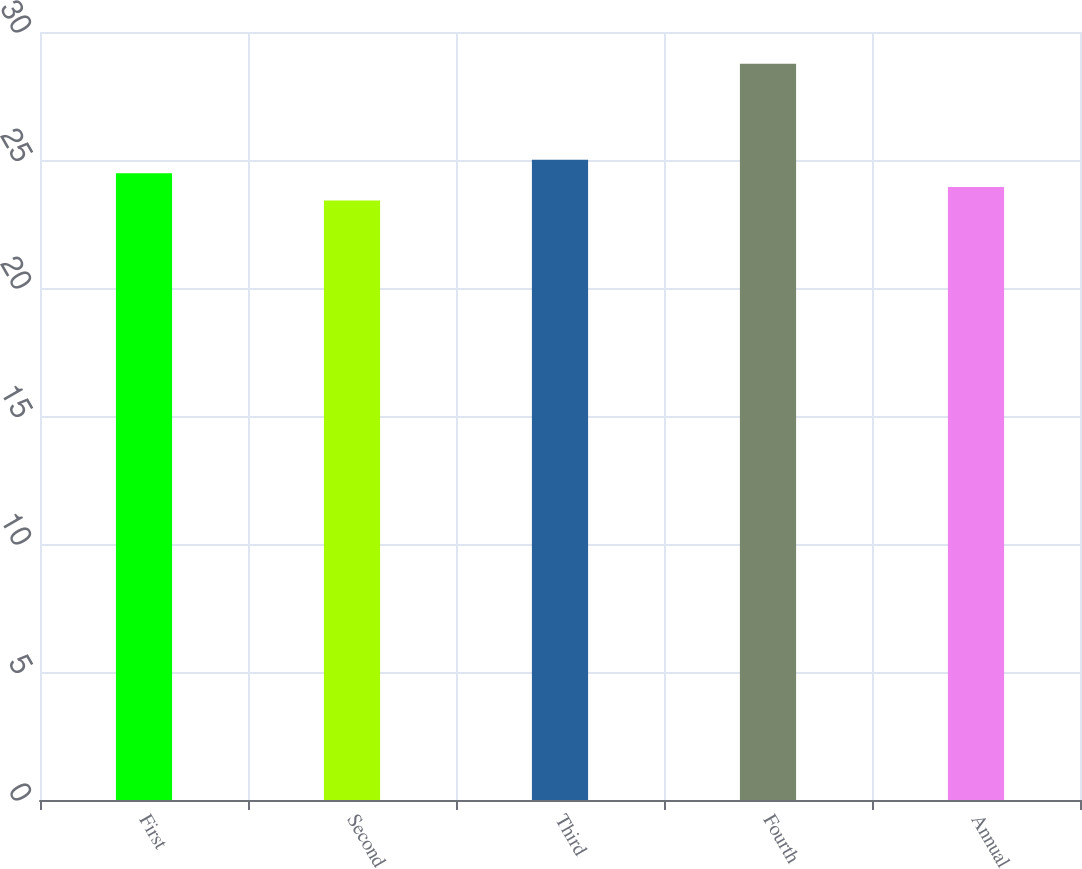<chart> <loc_0><loc_0><loc_500><loc_500><bar_chart><fcel>First<fcel>Second<fcel>Third<fcel>Fourth<fcel>Annual<nl><fcel>24.48<fcel>23.42<fcel>25.01<fcel>28.76<fcel>23.95<nl></chart> 